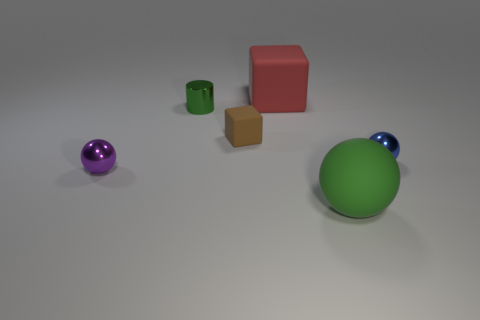Subtract all big green balls. How many balls are left? 2 Add 2 tiny purple objects. How many objects exist? 8 Subtract all gray balls. Subtract all green blocks. How many balls are left? 3 Subtract all cubes. How many objects are left? 4 Subtract all tiny balls. Subtract all tiny matte cubes. How many objects are left? 3 Add 2 brown objects. How many brown objects are left? 3 Add 3 big blue matte balls. How many big blue matte balls exist? 3 Subtract 0 yellow cubes. How many objects are left? 6 